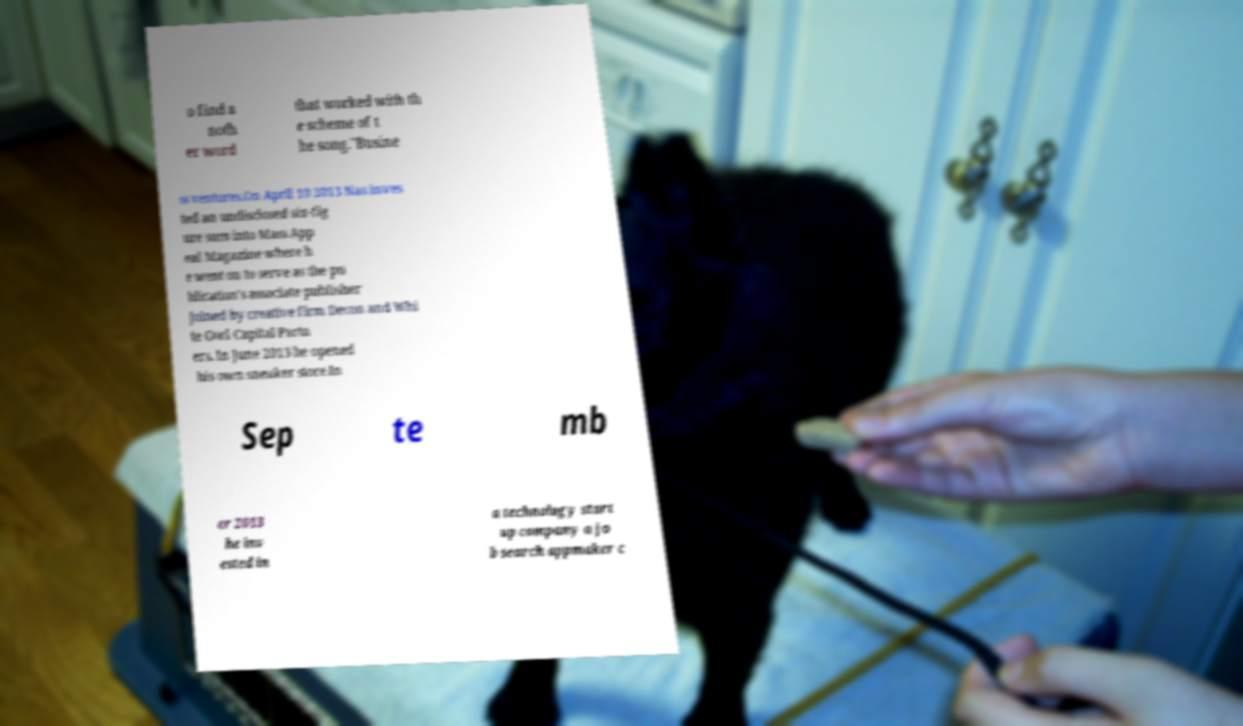Please identify and transcribe the text found in this image. o find a noth er word that worked with th e scheme of t he song."Busine ss ventures.On April 10 2013 Nas inves ted an undisclosed six-fig ure sum into Mass App eal Magazine where h e went on to serve as the pu blication's associate publisher joined by creative firm Decon and Whi te Owl Capital Partn ers. In June 2013 he opened his own sneaker store.In Sep te mb er 2013 he inv ested in a technology start up company a jo b search appmaker c 